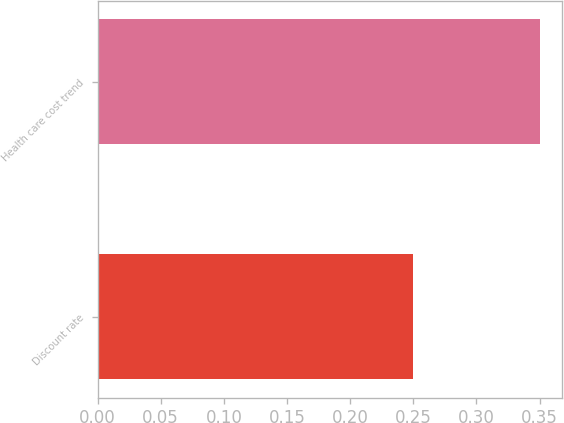<chart> <loc_0><loc_0><loc_500><loc_500><bar_chart><fcel>Discount rate<fcel>Health care cost trend<nl><fcel>0.25<fcel>0.35<nl></chart> 